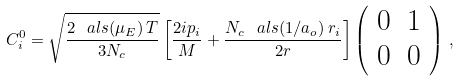Convert formula to latex. <formula><loc_0><loc_0><loc_500><loc_500>C ^ { 0 } _ { i } = \sqrt { \frac { 2 \, \ a l s ( \mu _ { E } ) \, T } { 3 N _ { c } } } \left [ \frac { 2 i p _ { i } } { M } + \frac { N _ { c } \, \ a l s ( 1 / a _ { o } ) \, r _ { i } } { 2 r } \right ] \left ( \begin{array} { c c } 0 & 1 \\ 0 & 0 \end{array} \right ) \, ,</formula> 